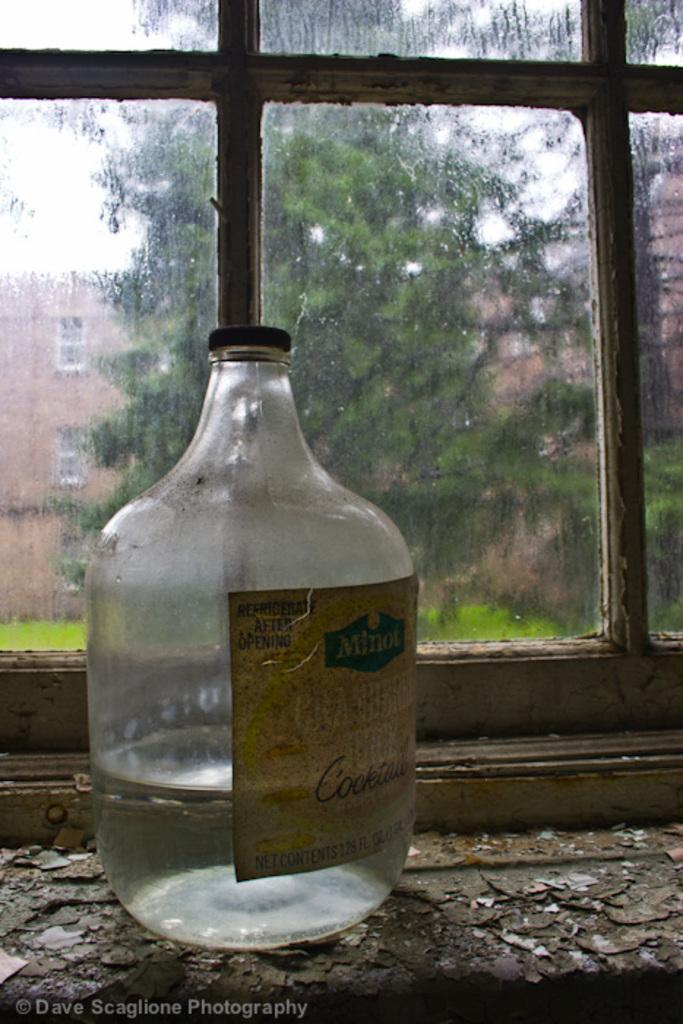<image>
Offer a succinct explanation of the picture presented. A jar with liquid in it with a label that says Minot Cocktail on it. 